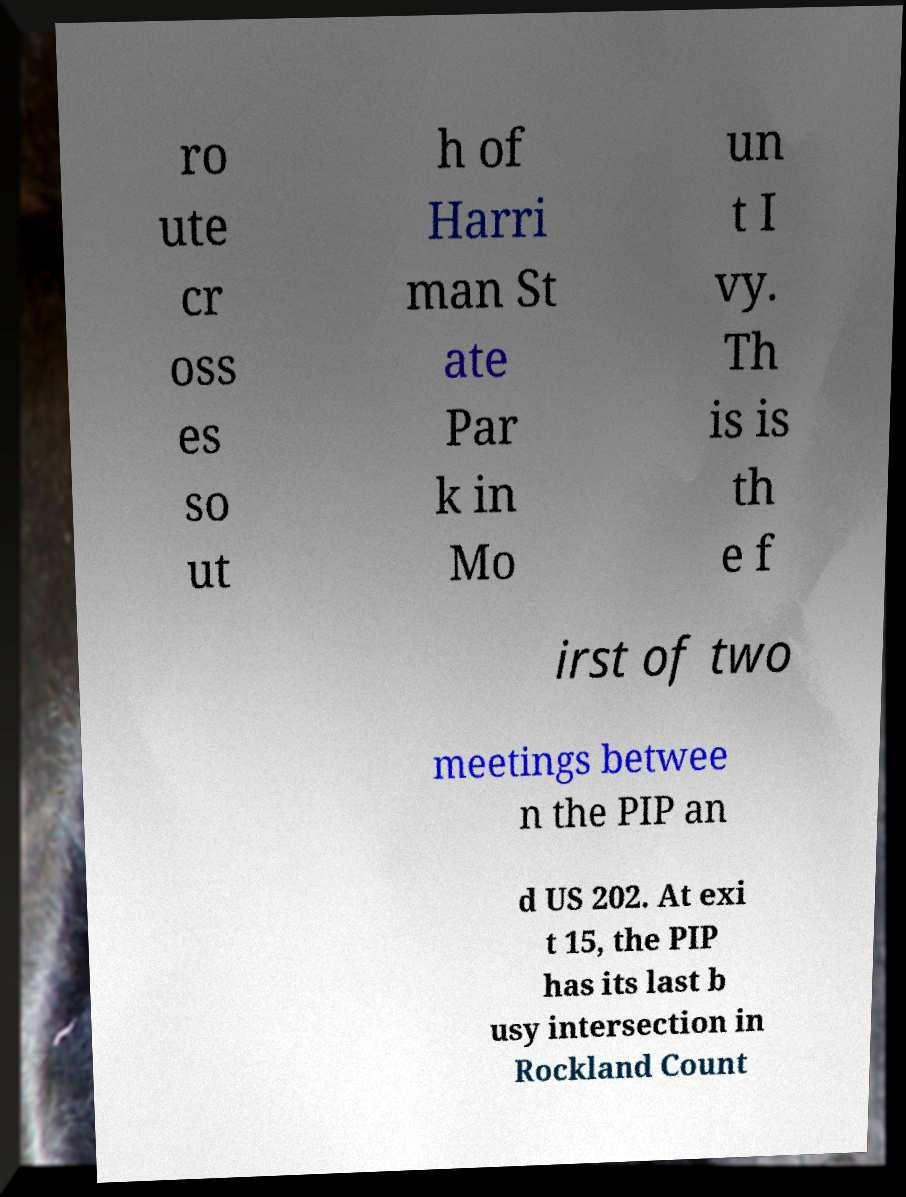Could you extract and type out the text from this image? ro ute cr oss es so ut h of Harri man St ate Par k in Mo un t I vy. Th is is th e f irst of two meetings betwee n the PIP an d US 202. At exi t 15, the PIP has its last b usy intersection in Rockland Count 